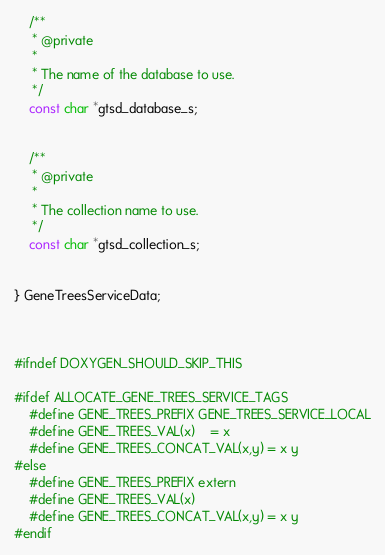<code> <loc_0><loc_0><loc_500><loc_500><_C_>	/**
	 * @private
	 *
	 * The name of the database to use.
	 */
	const char *gtsd_database_s;


	/**
	 * @private
	 *
	 * The collection name to use.
	 */
	const char *gtsd_collection_s;


} GeneTreesServiceData;



#ifndef DOXYGEN_SHOULD_SKIP_THIS

#ifdef ALLOCATE_GENE_TREES_SERVICE_TAGS
	#define GENE_TREES_PREFIX GENE_TREES_SERVICE_LOCAL
	#define GENE_TREES_VAL(x)	= x
	#define GENE_TREES_CONCAT_VAL(x,y) = x y
#else
	#define GENE_TREES_PREFIX extern
	#define GENE_TREES_VAL(x)
	#define GENE_TREES_CONCAT_VAL(x,y) = x y
#endif
</code> 